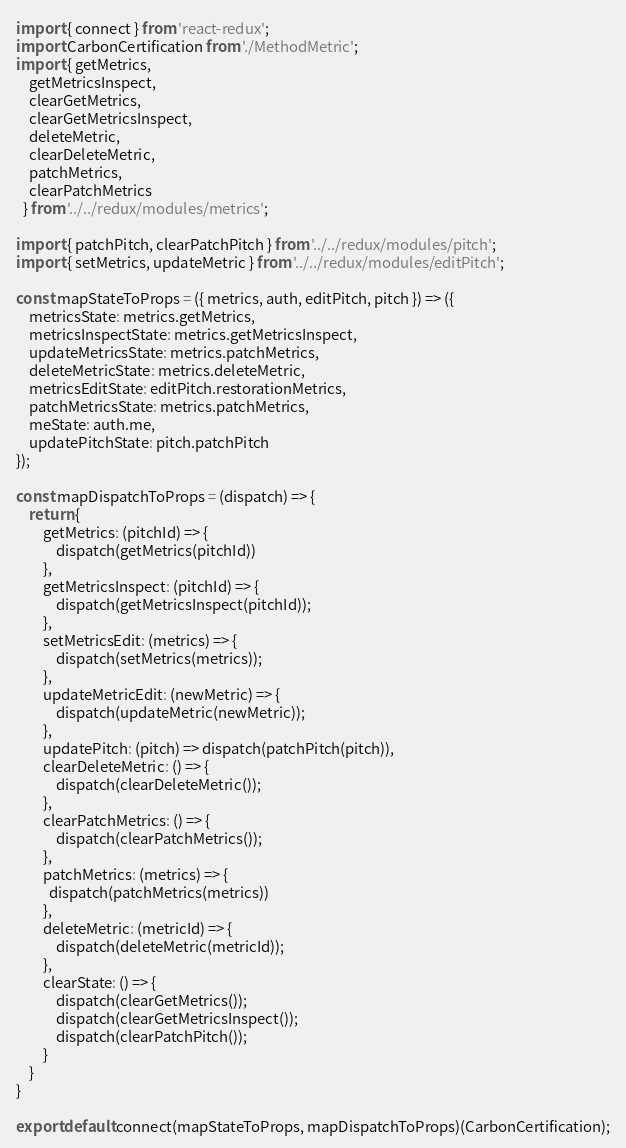<code> <loc_0><loc_0><loc_500><loc_500><_JavaScript_>import { connect } from 'react-redux';
import CarbonCertification from './MethodMetric';
import { getMetrics,
    getMetricsInspect,
    clearGetMetrics,
    clearGetMetricsInspect,
    deleteMetric,
    clearDeleteMetric,
    patchMetrics,
    clearPatchMetrics
  } from '../../redux/modules/metrics';

import { patchPitch, clearPatchPitch } from '../../redux/modules/pitch';
import { setMetrics, updateMetric } from '../../redux/modules/editPitch';

const mapStateToProps = ({ metrics, auth, editPitch, pitch }) => ({
    metricsState: metrics.getMetrics,
    metricsInspectState: metrics.getMetricsInspect,
    updateMetricsState: metrics.patchMetrics,
    deleteMetricState: metrics.deleteMetric,
    metricsEditState: editPitch.restorationMetrics,
    patchMetricsState: metrics.patchMetrics,
    meState: auth.me,
    updatePitchState: pitch.patchPitch
});

const mapDispatchToProps = (dispatch) => {
    return {
        getMetrics: (pitchId) => {
            dispatch(getMetrics(pitchId))
        },
        getMetricsInspect: (pitchId) => {
            dispatch(getMetricsInspect(pitchId));
        },
        setMetricsEdit: (metrics) => {
            dispatch(setMetrics(metrics));
        },
        updateMetricEdit: (newMetric) => {
            dispatch(updateMetric(newMetric));
        },
        updatePitch: (pitch) => dispatch(patchPitch(pitch)),
        clearDeleteMetric: () => {
            dispatch(clearDeleteMetric());
        },
        clearPatchMetrics: () => {
            dispatch(clearPatchMetrics());
        },
        patchMetrics: (metrics) => {
          dispatch(patchMetrics(metrics))
        },
        deleteMetric: (metricId) => {
            dispatch(deleteMetric(metricId));
        },
        clearState: () => {
            dispatch(clearGetMetrics());
            dispatch(clearGetMetricsInspect());
            dispatch(clearPatchPitch());
        }
    }
}

export default connect(mapStateToProps, mapDispatchToProps)(CarbonCertification);
</code> 